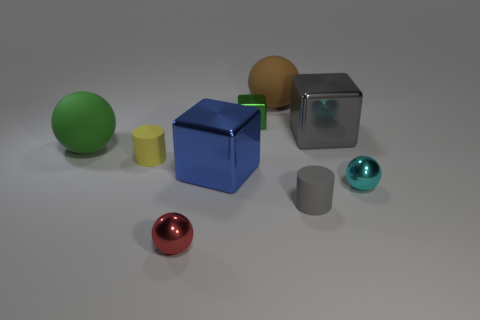Add 1 big green balls. How many objects exist? 10 Subtract all brown spheres. How many spheres are left? 3 Subtract all big blocks. How many blocks are left? 1 Subtract all yellow cylinders. How many purple blocks are left? 0 Subtract all green matte spheres. Subtract all cyan balls. How many objects are left? 7 Add 9 gray matte cylinders. How many gray matte cylinders are left? 10 Add 8 small cyan metal objects. How many small cyan metal objects exist? 9 Subtract 1 green cubes. How many objects are left? 8 Subtract all balls. How many objects are left? 5 Subtract 1 cubes. How many cubes are left? 2 